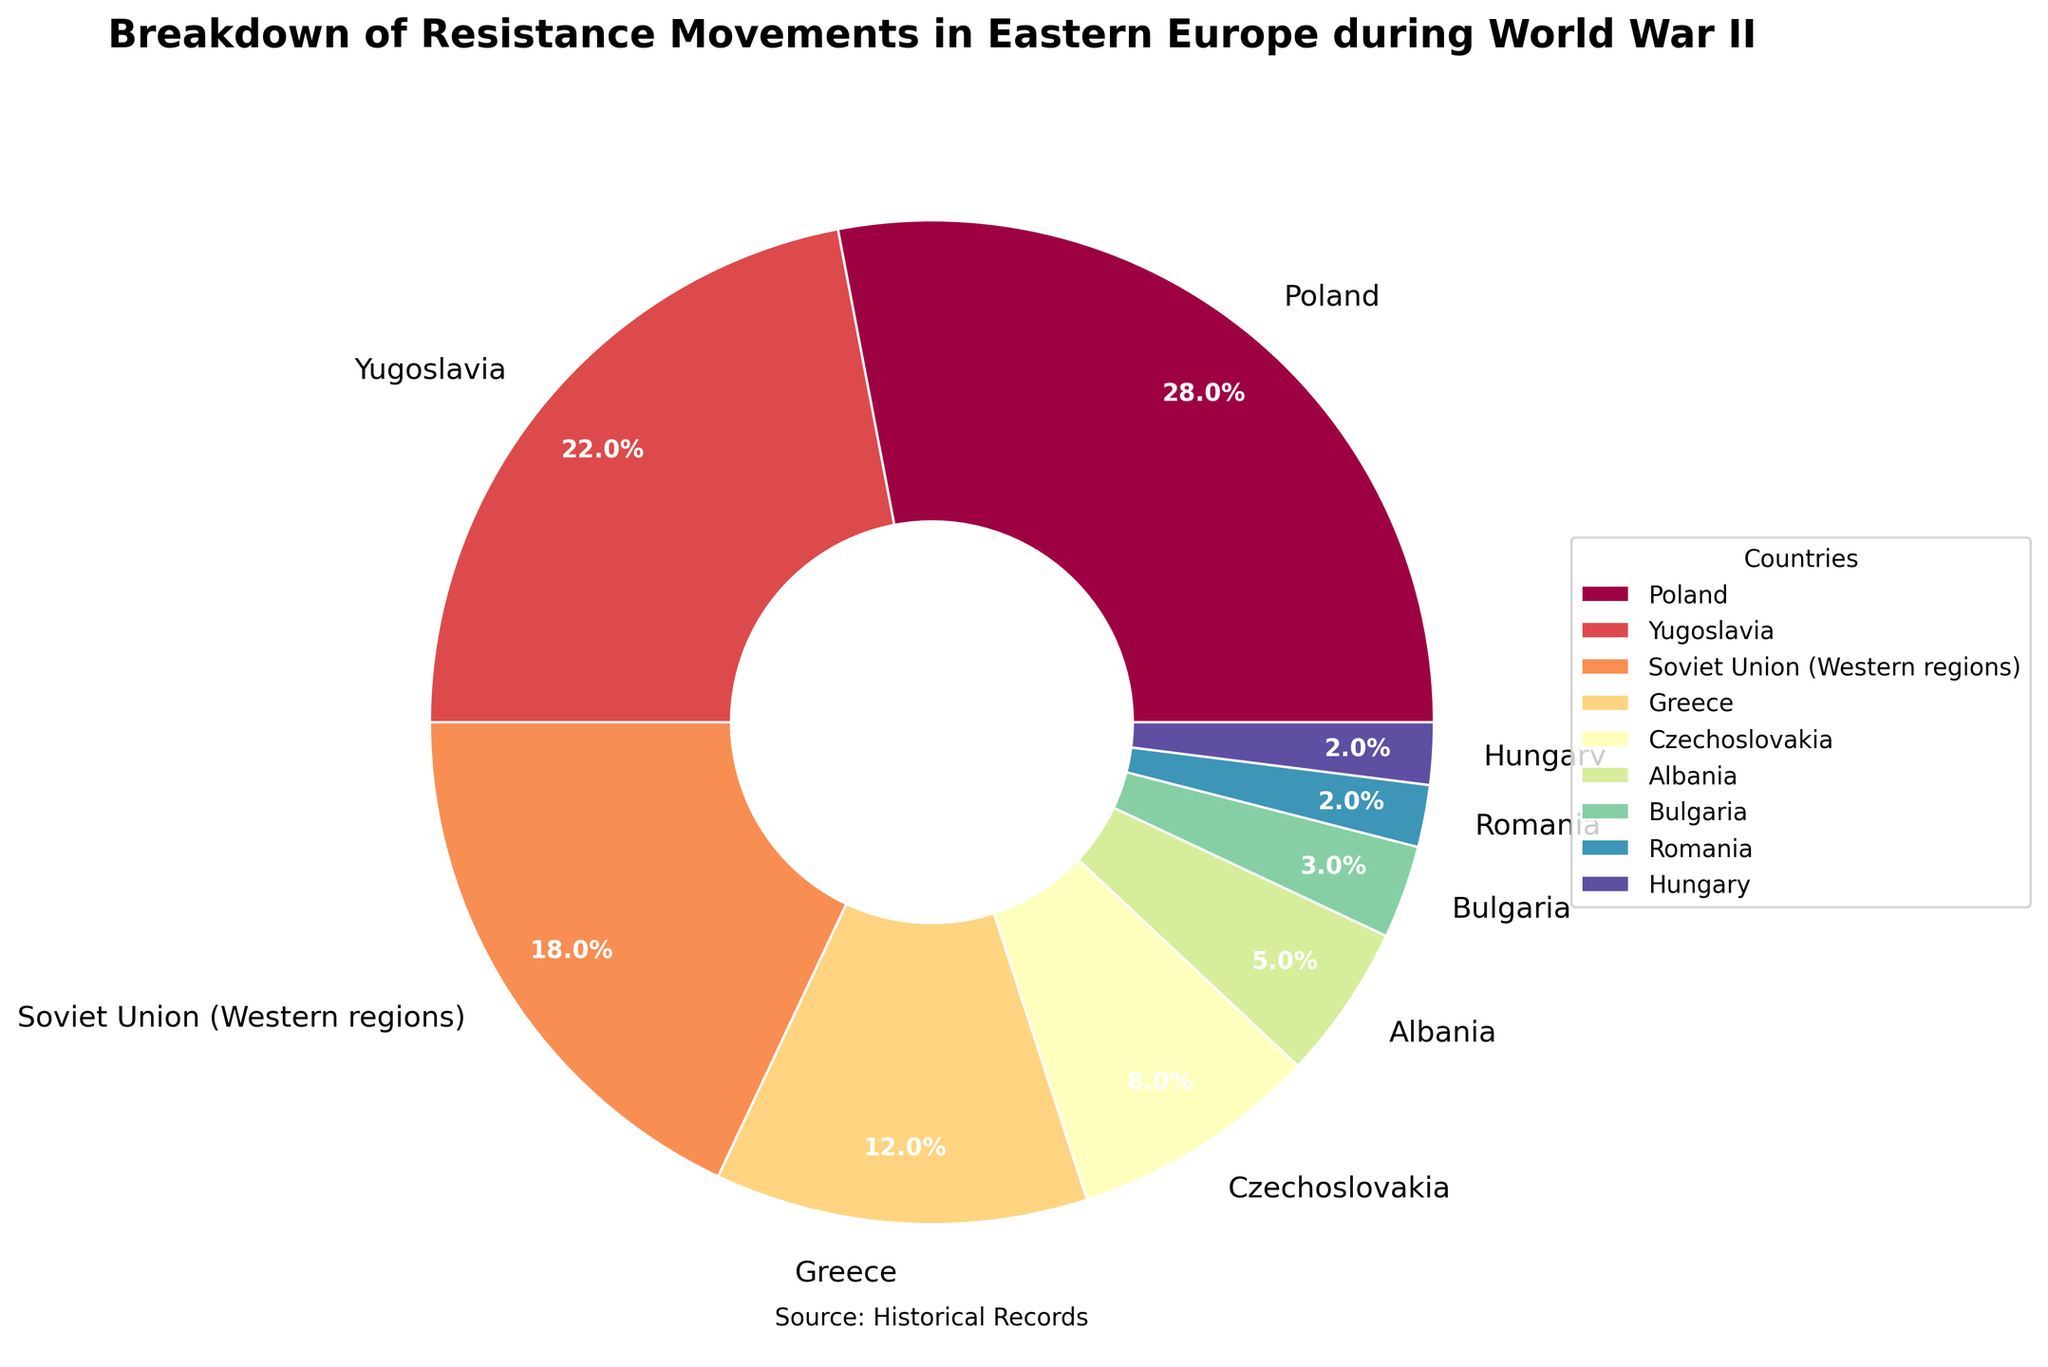What country has the highest percentage of resistance activity? The figure shows that Poland has the largest slice in the pie chart, representing 28% of resistance activity.
Answer: Poland Which countries have a resistance activity percentage equal to or less than 5%? By examining the pie chart, we see that Albania, Bulgaria, Romania, and Hungary all have slices of 5% or less.
Answer: Albania, Bulgaria, Romania, Hungary What is the combined percentage of resistance activities in Bulgaria, Romania, and Hungary? By adding the percentages provided in the pie chart for Bulgaria (3%), Romania (2%), and Hungary (2%), we get 3% + 2% + 2% = 7%.
Answer: 7% How does Greece's resistance activity compare with Czechoslovakia's? The pie chart indicates that Greece has 12% of resistance activity while Czechoslovakia has 8%, showing that Greece's is higher.
Answer: Greece's is higher Among the countries listed, which has the smallest share of resistance activity, and what is its percentage? The smallest slice in the pie chart belongs to Hungary, representing 2% of the resistance activity.
Answer: Hungary, 2% Which country contributes more to resistance activities, Yugoslavia or the Soviet Union (Western regions)? The pie chart shows that Yugoslavia has 22% and the Soviet Union (Western regions) has 18%, making Yugoslavia's contribution greater.
Answer: Yugoslavia What is the difference in resistance activity between Poland and the Soviet Union (Western regions)? Poland has 28% and the Soviet Union (Western regions) has 18%. The difference is 28% - 18% = 10%.
Answer: 10% Rank the top three countries by percentage of resistance activity. The pie chart shows the following top three countries: 1) Poland (28%), 2) Yugoslavia (22%), and 3) Soviet Union (Western regions) (18%).
Answer: Poland, Yugoslavia, Soviet Union (Western regions) What is the total percentage of resistance activities when combining Greece and Czechoslovakia? The pie chart indicates Greece has 12% and Czechoslovakia has 8%. The total is 12% + 8% = 20%.
Answer: 20% If you combine the resistance activities of Albania and Bulgaria, how does this compare to that of Greece? Albania has 5% and Bulgaria has 3%, giving 5% + 3% = 8%, while Greece has 12%. Hence, Greece's resistance activity is higher.
Answer: Greece's is higher 